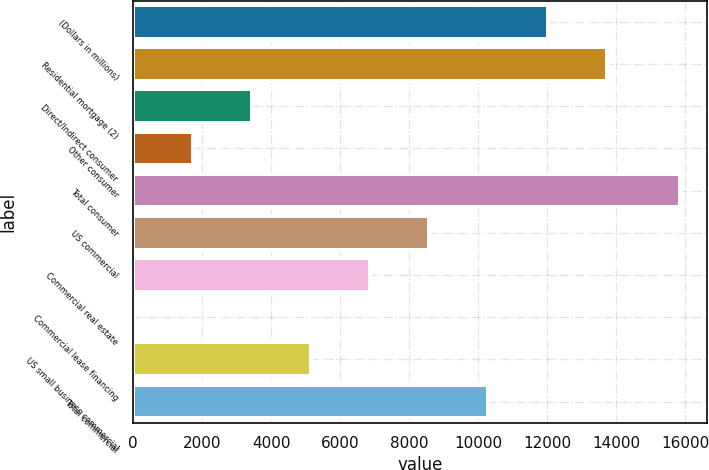<chart> <loc_0><loc_0><loc_500><loc_500><bar_chart><fcel>(Dollars in millions)<fcel>Residential mortgage (2)<fcel>Direct/Indirect consumer<fcel>Other consumer<fcel>Total consumer<fcel>US commercial<fcel>Commercial real estate<fcel>Commercial lease financing<fcel>US small business commercial<fcel>Total commercial<nl><fcel>12009.1<fcel>13722.4<fcel>3442.6<fcel>1729.3<fcel>15840<fcel>8582.5<fcel>6869.2<fcel>16<fcel>5155.9<fcel>10295.8<nl></chart> 